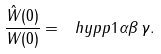<formula> <loc_0><loc_0><loc_500><loc_500>\frac { \hat { W } ( 0 ) } { W ( 0 ) } = \ h y p p { 1 } { \alpha } { \beta \, } { \gamma } .</formula> 